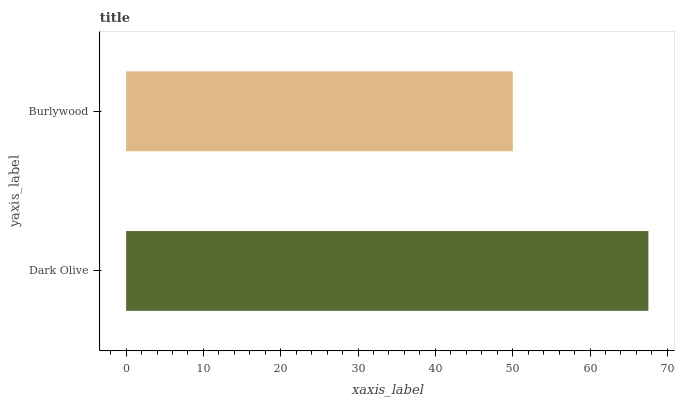Is Burlywood the minimum?
Answer yes or no. Yes. Is Dark Olive the maximum?
Answer yes or no. Yes. Is Burlywood the maximum?
Answer yes or no. No. Is Dark Olive greater than Burlywood?
Answer yes or no. Yes. Is Burlywood less than Dark Olive?
Answer yes or no. Yes. Is Burlywood greater than Dark Olive?
Answer yes or no. No. Is Dark Olive less than Burlywood?
Answer yes or no. No. Is Dark Olive the high median?
Answer yes or no. Yes. Is Burlywood the low median?
Answer yes or no. Yes. Is Burlywood the high median?
Answer yes or no. No. Is Dark Olive the low median?
Answer yes or no. No. 